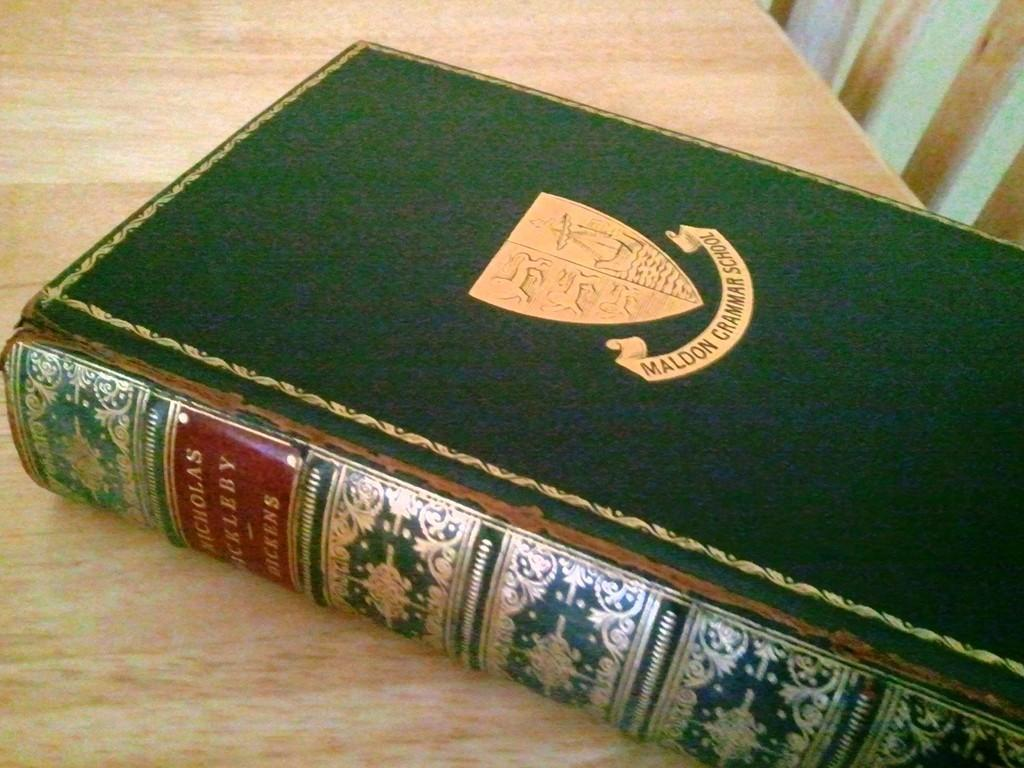<image>
Summarize the visual content of the image. A book with a green covered Labels Maldoni Grammar School sits on a table. 